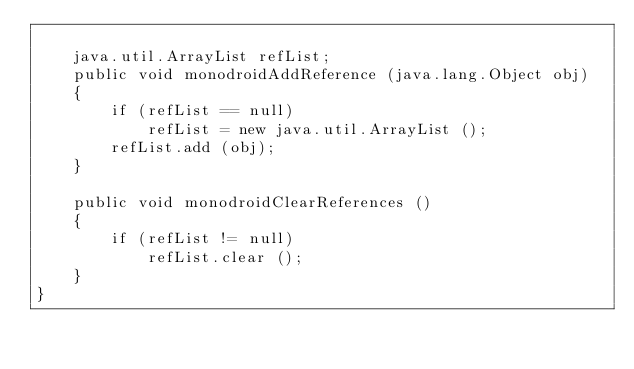<code> <loc_0><loc_0><loc_500><loc_500><_Java_>
	java.util.ArrayList refList;
	public void monodroidAddReference (java.lang.Object obj)
	{
		if (refList == null)
			refList = new java.util.ArrayList ();
		refList.add (obj);
	}

	public void monodroidClearReferences ()
	{
		if (refList != null)
			refList.clear ();
	}
}
</code> 